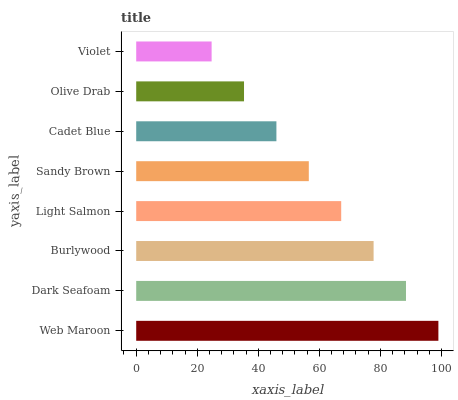Is Violet the minimum?
Answer yes or no. Yes. Is Web Maroon the maximum?
Answer yes or no. Yes. Is Dark Seafoam the minimum?
Answer yes or no. No. Is Dark Seafoam the maximum?
Answer yes or no. No. Is Web Maroon greater than Dark Seafoam?
Answer yes or no. Yes. Is Dark Seafoam less than Web Maroon?
Answer yes or no. Yes. Is Dark Seafoam greater than Web Maroon?
Answer yes or no. No. Is Web Maroon less than Dark Seafoam?
Answer yes or no. No. Is Light Salmon the high median?
Answer yes or no. Yes. Is Sandy Brown the low median?
Answer yes or no. Yes. Is Dark Seafoam the high median?
Answer yes or no. No. Is Violet the low median?
Answer yes or no. No. 